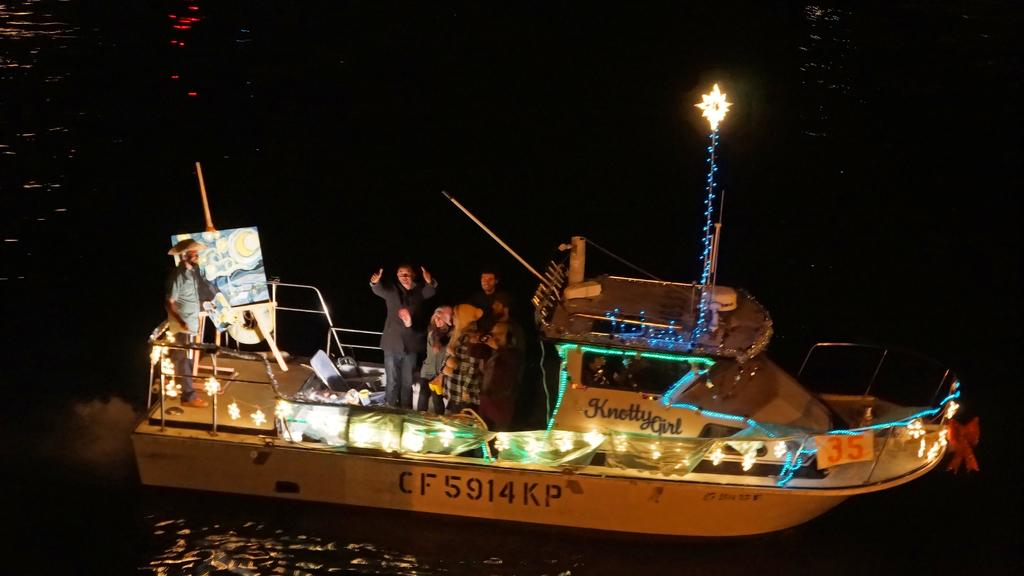What type of vehicle is in the image? There is a white boat in the image. What are the people in the boat doing? The people are standing in the boat and posing for a camera. What is the color of the background in the image? The background of the image is dark. Can you see any bones in the image? There are no bones visible in the image. Is there any steam coming from the boat in the image? There is no steam present in the image. 